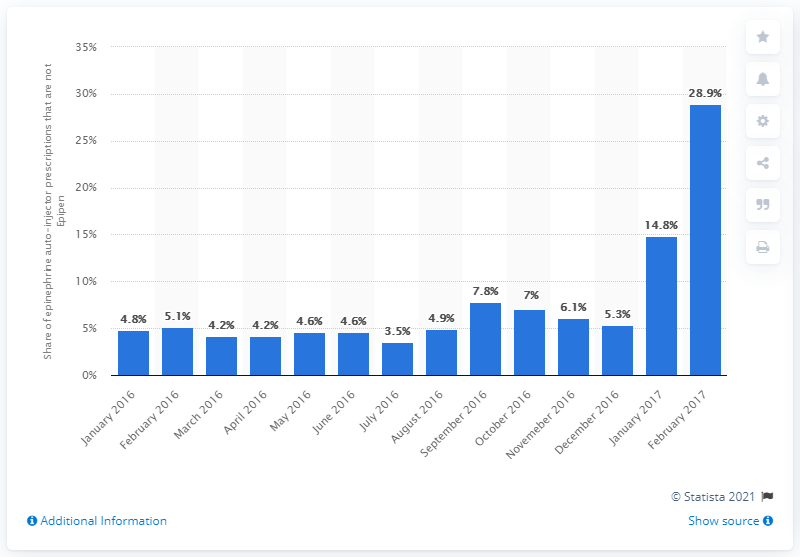Mention a couple of crucial points in this snapshot. According to data from February 2017, alternative epinephrine auto-injectors accounted for 28.9% of all prescriptions written. 